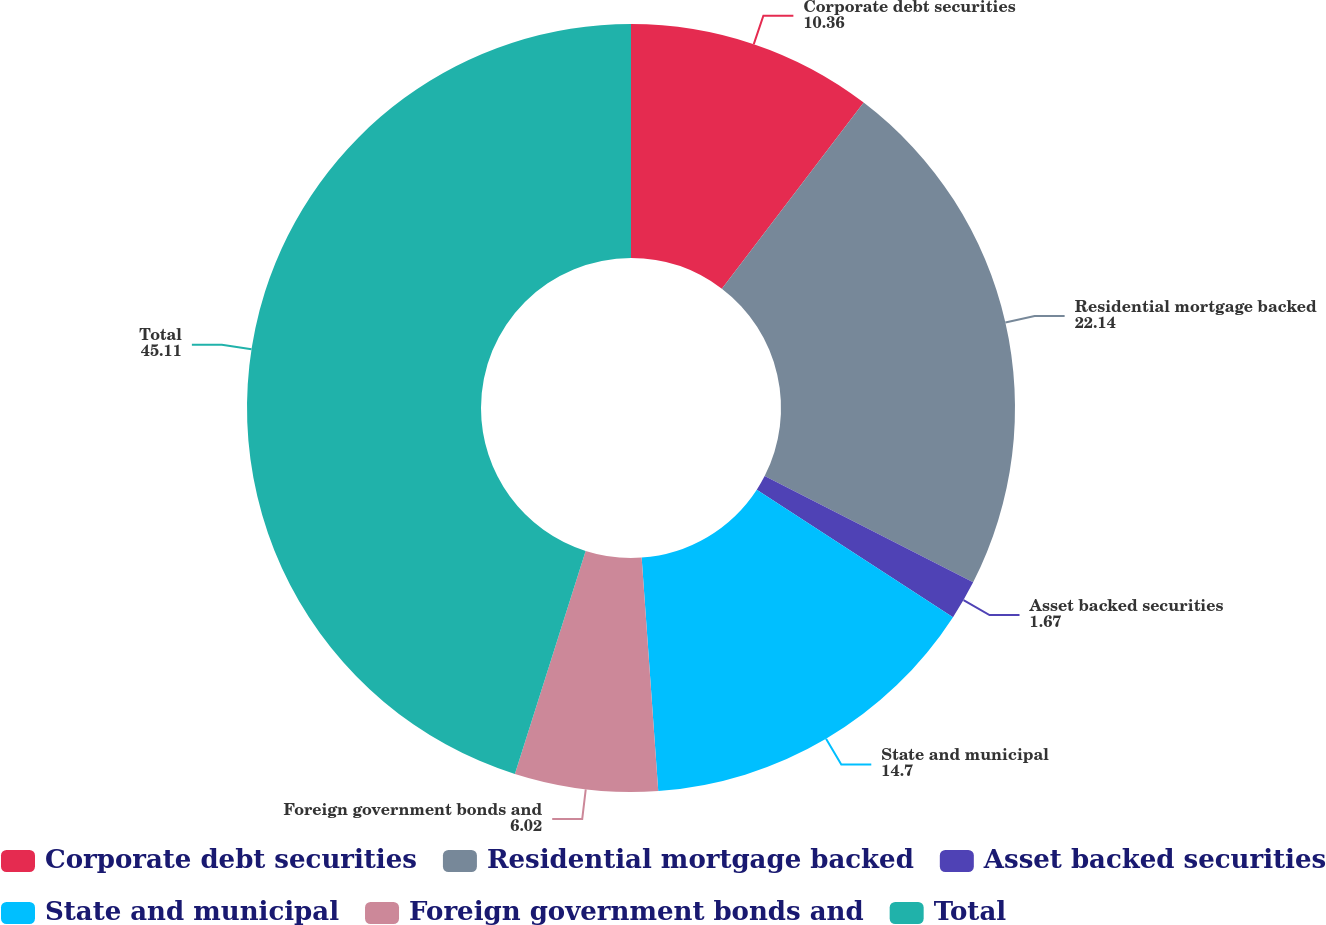<chart> <loc_0><loc_0><loc_500><loc_500><pie_chart><fcel>Corporate debt securities<fcel>Residential mortgage backed<fcel>Asset backed securities<fcel>State and municipal<fcel>Foreign government bonds and<fcel>Total<nl><fcel>10.36%<fcel>22.14%<fcel>1.67%<fcel>14.7%<fcel>6.02%<fcel>45.11%<nl></chart> 